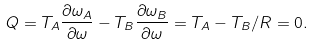<formula> <loc_0><loc_0><loc_500><loc_500>Q = T _ { A } { \frac { \partial \omega _ { A } } { \partial \omega } } - T _ { B } { \frac { \partial \omega _ { B } } { \partial \omega } } = T _ { A } - T _ { B } / R = 0 .</formula> 